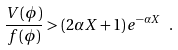<formula> <loc_0><loc_0><loc_500><loc_500>\frac { V ( \phi ) } { f ( \phi ) } > ( 2 \alpha X + 1 ) e ^ { - \alpha X } \ .</formula> 